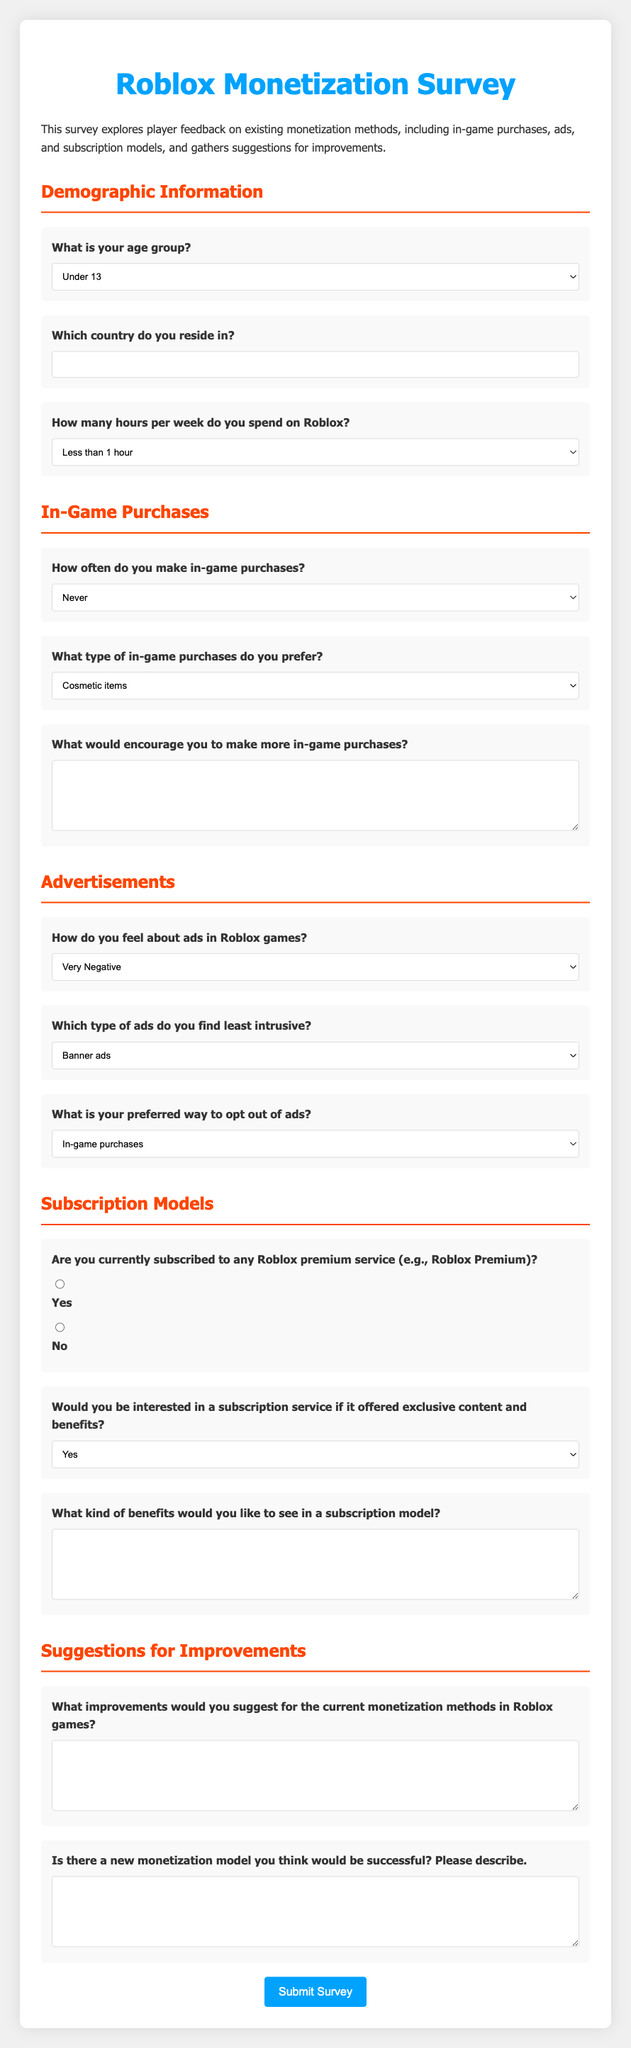What is the primary purpose of the survey? The survey explores player feedback on existing monetization methods and gathers suggestions for improvements.
Answer: Feedback on monetization methods What age group options are provided in the survey? The survey lists several age groups for respondents to select from, including options like "Under 13," "13-18," and so on.
Answer: Under 13, 13-18, 19-25, 26-35, 36-50, Over 50 What type of in-game purchases are mentioned as preferred by players? The survey provides around five options for the type of in-game purchases, such as currency packs and cosmetic items.
Answer: Cosmetic items, Game passes, Power-ups, Currency packs How do respondents feel about ads in Roblox games? The survey asks for opinions on ads, providing a range of feelings from very negative to very positive.
Answer: Very Negative, Somewhat Negative, Neutral, Somewhat Positive, Very Positive What is a suggested way for players to opt out of ads? The survey includes options for players to choose how they prefer to opt out of ads, including in-game purchases and subscription models.
Answer: In-game purchases, Subscription models, Watching more ads upfront What suggestions does the survey seek regarding monetization improvements? The survey asks respondents to provide their suggestions for improving current monetization methods.
Answer: Suggestions for improvements Would players consider subscribing to a premium service? The survey asks if players would be interested in a subscription service offering exclusive content, with possible responses ranging from yes to maybe.
Answer: Yes, No, Maybe What demographic information is requested in the survey? The survey collects information about age, country of residence, and weekly hours spent on Roblox.
Answer: Age, Country, Weekly hours 